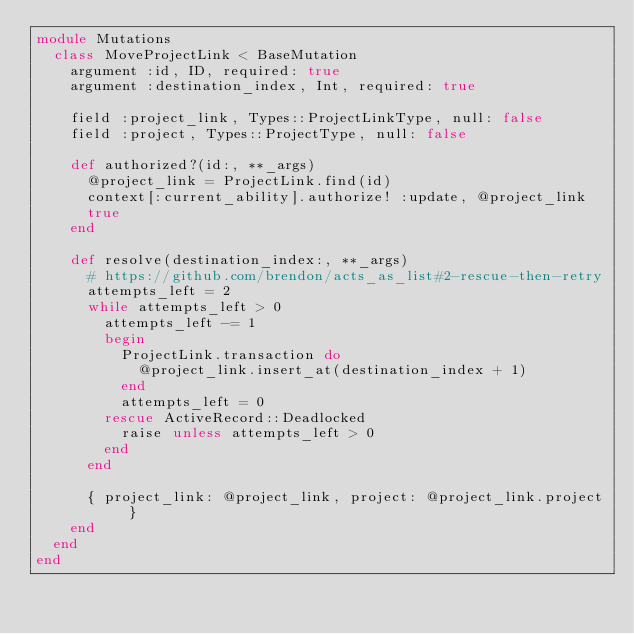Convert code to text. <code><loc_0><loc_0><loc_500><loc_500><_Ruby_>module Mutations
  class MoveProjectLink < BaseMutation
    argument :id, ID, required: true
    argument :destination_index, Int, required: true

    field :project_link, Types::ProjectLinkType, null: false
    field :project, Types::ProjectType, null: false

    def authorized?(id:, **_args)
      @project_link = ProjectLink.find(id)
      context[:current_ability].authorize! :update, @project_link
      true
    end

    def resolve(destination_index:, **_args)
      # https://github.com/brendon/acts_as_list#2-rescue-then-retry
      attempts_left = 2
      while attempts_left > 0
        attempts_left -= 1
        begin
          ProjectLink.transaction do
            @project_link.insert_at(destination_index + 1)
          end
          attempts_left = 0
        rescue ActiveRecord::Deadlocked
          raise unless attempts_left > 0
        end
      end

      { project_link: @project_link, project: @project_link.project }
    end
  end
end
</code> 